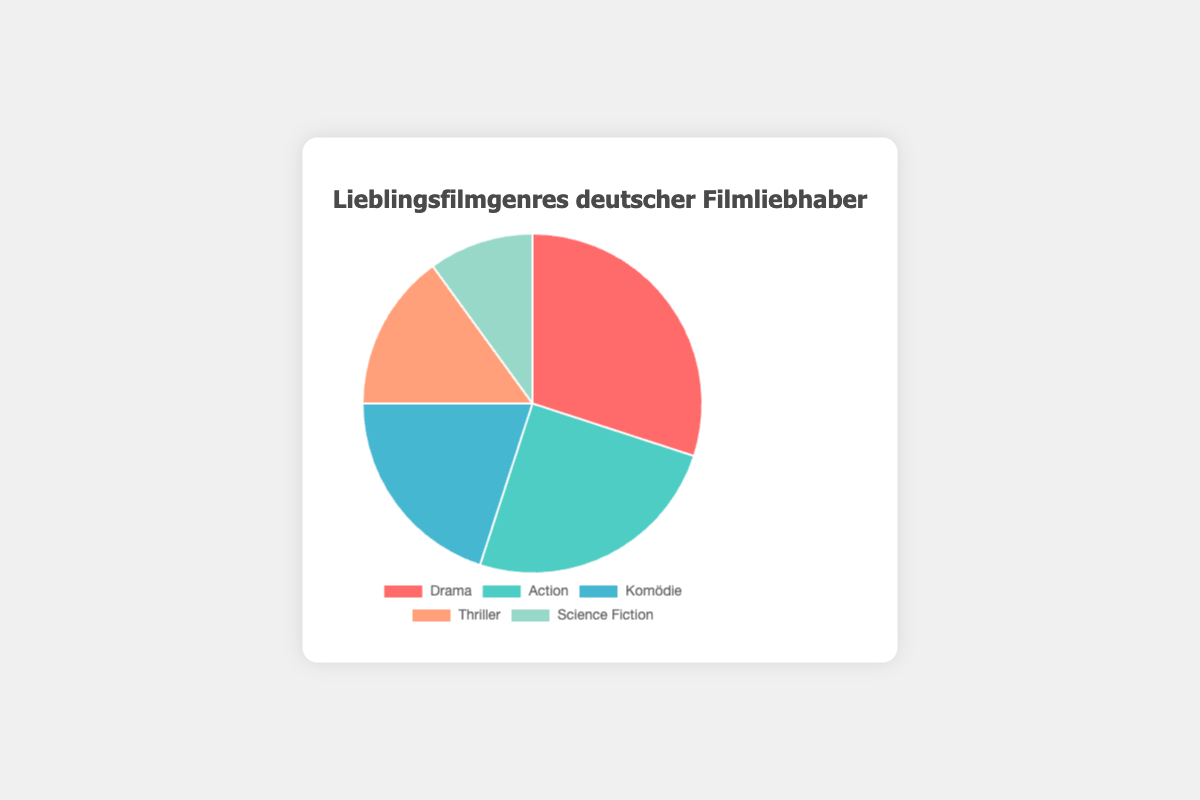What's the most popular movie genre among German film enthusiasts? According to the pie chart, the red section representing Drama has the largest size, indicating it is the most popular genre.
Answer: Drama Which movie genre is preferred the least by German film enthusiasts? The smallest section of the pie chart, represented by the light green color, indicates that Science Fiction is the least preferred genre.
Answer: Science Fiction How much more popular is Drama compared to Science Fiction? Drama accounts for 30% of preferences, while Science Fiction accounts for 10%. The difference is 30% - 10% = 20%.
Answer: 20% If we combine the preferences for Comedy and Thriller, what is their total percentage? The percentages for Comedy and Thriller are 20% and 15%, respectively. Their combined total is 20% + 15% = 35%.
Answer: 35% Which genre represents a quarter of the total preferences? By observing the percentages, the genre represented by 25% is Action.
Answer: Action Which two genres have a combined percentage that equals the percentage for Drama? The percentages for Comedy and Thriller are 20% and 15%, respectively. Their combined percentage is 20% + 15% = 35%, which does not match Drama's 30%. However, Action and Science Fiction together equal 25% + 10% = 35%, but no two genres add to Drama’s percentage. Hence, there are no such pairs.
Answer: None Which genre has a percentage exactly double of Science Fiction? Science Fiction has 10%, and the genre with exactly double this percentage is Thriller with 15%, as there's no exact match. But the next closest genre is Comedy with 20%.
Answer: Comedy What percentage of the chart is represented by non-Drama genres? Subtract Drama's percentage from 100%. That is: 100% - 30% = 70%.
Answer: 70% Among Action and Thriller, which genre is more popular? Comparing the sizes of Action and Thriller, Action has 25%, which is greater than Thriller's 15%.
Answer: Action 